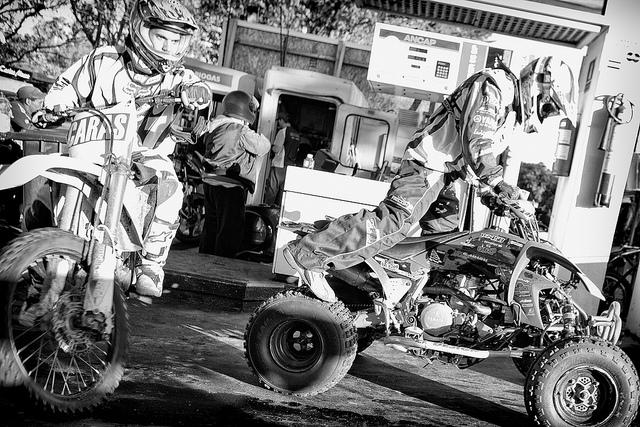What is the man on the right riding? Please explain your reasoning. quad. The man is in a quad. 